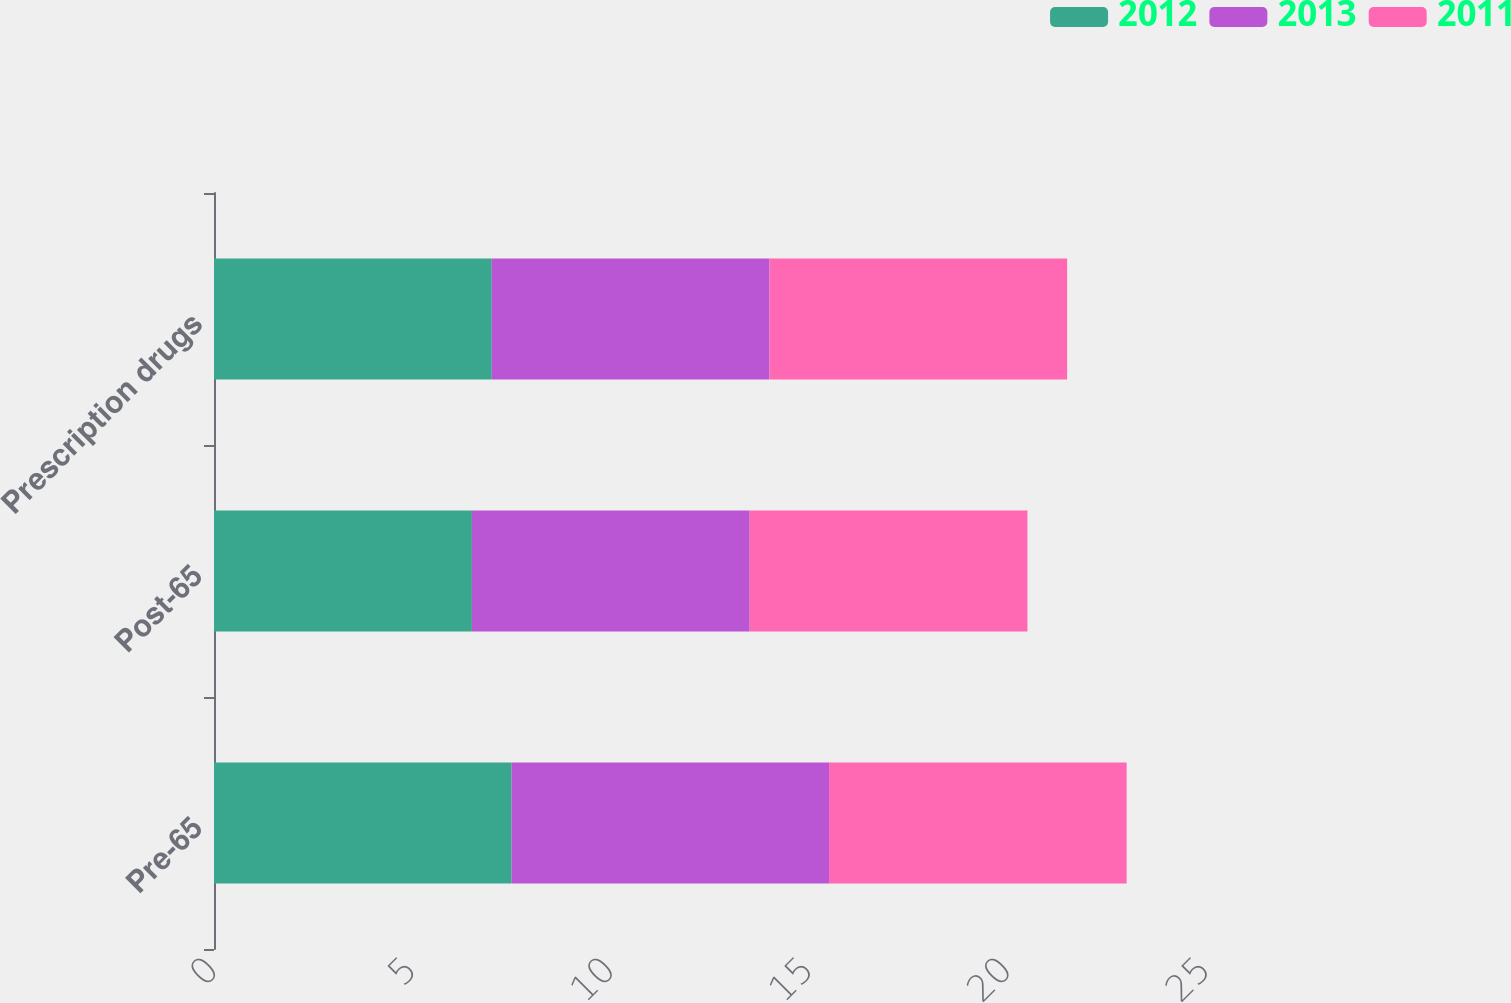Convert chart to OTSL. <chart><loc_0><loc_0><loc_500><loc_500><stacked_bar_chart><ecel><fcel>Pre-65<fcel>Post-65<fcel>Prescription drugs<nl><fcel>2012<fcel>7.5<fcel>6.5<fcel>7<nl><fcel>2013<fcel>8<fcel>7<fcel>7<nl><fcel>2011<fcel>7.5<fcel>7<fcel>7.5<nl></chart> 